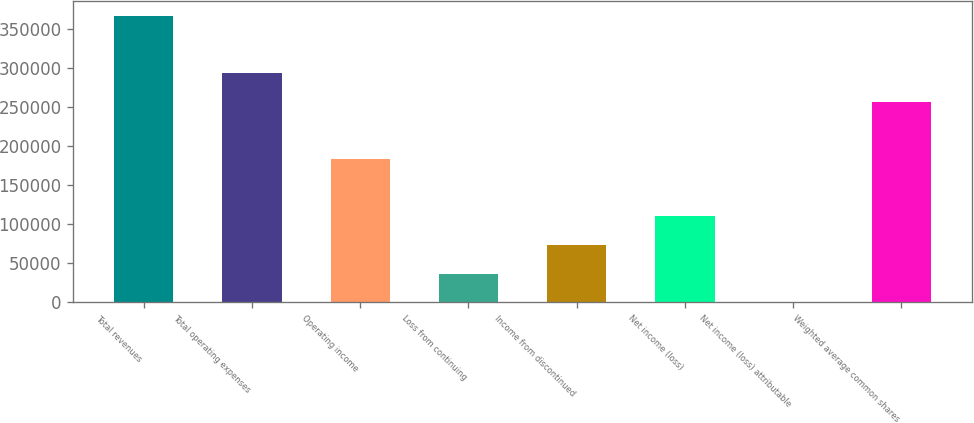Convert chart. <chart><loc_0><loc_0><loc_500><loc_500><bar_chart><fcel>Total revenues<fcel>Total operating expenses<fcel>Operating income<fcel>Loss from continuing<fcel>Income from discontinued<fcel>Net income (loss)<fcel>Net income (loss) attributable<fcel>Weighted average common shares<nl><fcel>366353<fcel>293082<fcel>183177<fcel>36635.5<fcel>73270.8<fcel>109906<fcel>0.19<fcel>256447<nl></chart> 